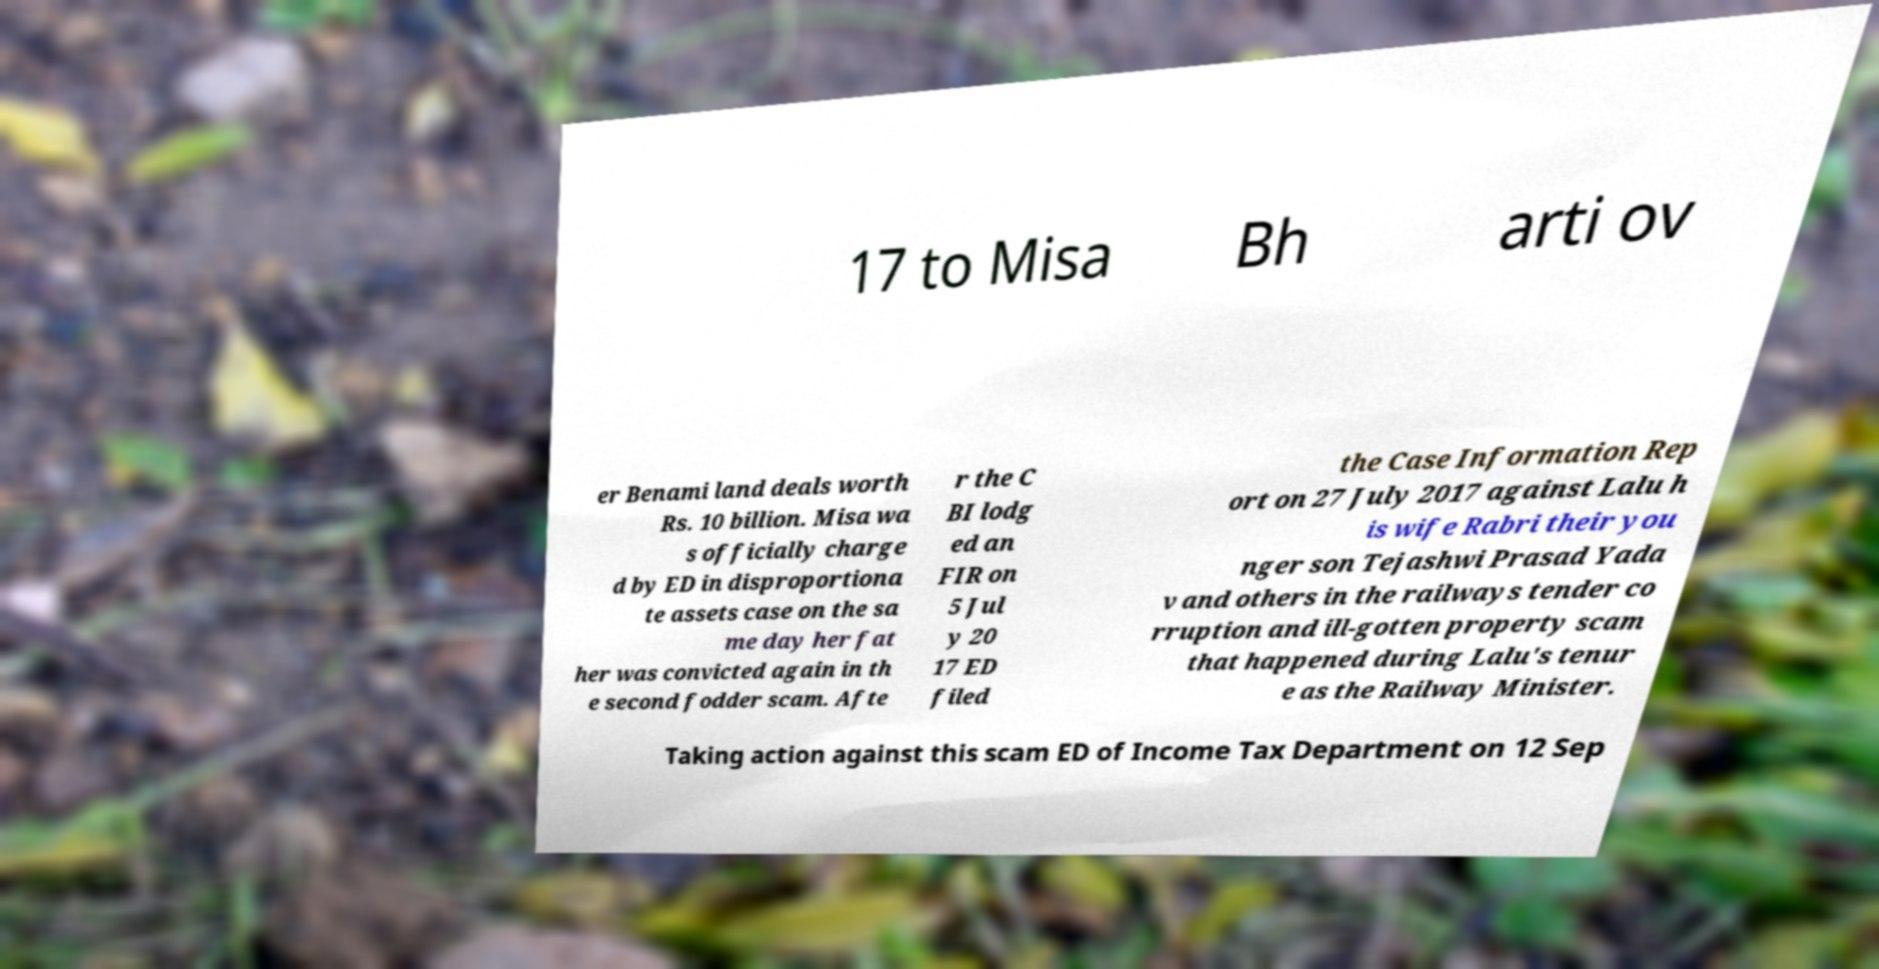What messages or text are displayed in this image? I need them in a readable, typed format. 17 to Misa Bh arti ov er Benami land deals worth Rs. 10 billion. Misa wa s officially charge d by ED in disproportiona te assets case on the sa me day her fat her was convicted again in th e second fodder scam. Afte r the C BI lodg ed an FIR on 5 Jul y 20 17 ED filed the Case Information Rep ort on 27 July 2017 against Lalu h is wife Rabri their you nger son Tejashwi Prasad Yada v and others in the railways tender co rruption and ill-gotten property scam that happened during Lalu's tenur e as the Railway Minister. Taking action against this scam ED of Income Tax Department on 12 Sep 